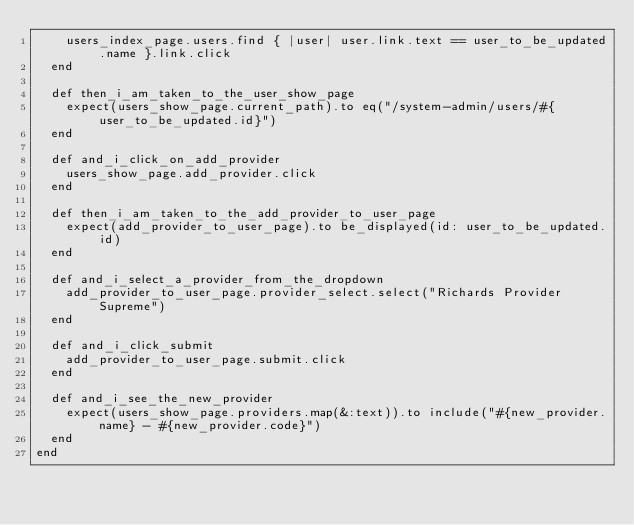Convert code to text. <code><loc_0><loc_0><loc_500><loc_500><_Ruby_>    users_index_page.users.find { |user| user.link.text == user_to_be_updated.name }.link.click
  end

  def then_i_am_taken_to_the_user_show_page
    expect(users_show_page.current_path).to eq("/system-admin/users/#{user_to_be_updated.id}")
  end

  def and_i_click_on_add_provider
    users_show_page.add_provider.click
  end

  def then_i_am_taken_to_the_add_provider_to_user_page
    expect(add_provider_to_user_page).to be_displayed(id: user_to_be_updated.id)
  end

  def and_i_select_a_provider_from_the_dropdown
    add_provider_to_user_page.provider_select.select("Richards Provider Supreme")
  end

  def and_i_click_submit
    add_provider_to_user_page.submit.click
  end

  def and_i_see_the_new_provider
    expect(users_show_page.providers.map(&:text)).to include("#{new_provider.name} - #{new_provider.code}")
  end
end
</code> 